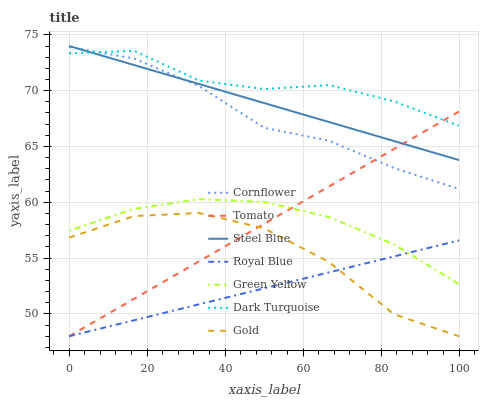Does Royal Blue have the minimum area under the curve?
Answer yes or no. Yes. Does Dark Turquoise have the maximum area under the curve?
Answer yes or no. Yes. Does Cornflower have the minimum area under the curve?
Answer yes or no. No. Does Cornflower have the maximum area under the curve?
Answer yes or no. No. Is Royal Blue the smoothest?
Answer yes or no. Yes. Is Gold the roughest?
Answer yes or no. Yes. Is Cornflower the smoothest?
Answer yes or no. No. Is Cornflower the roughest?
Answer yes or no. No. Does Tomato have the lowest value?
Answer yes or no. Yes. Does Cornflower have the lowest value?
Answer yes or no. No. Does Steel Blue have the highest value?
Answer yes or no. Yes. Does Cornflower have the highest value?
Answer yes or no. No. Is Royal Blue less than Dark Turquoise?
Answer yes or no. Yes. Is Steel Blue greater than Gold?
Answer yes or no. Yes. Does Steel Blue intersect Tomato?
Answer yes or no. Yes. Is Steel Blue less than Tomato?
Answer yes or no. No. Is Steel Blue greater than Tomato?
Answer yes or no. No. Does Royal Blue intersect Dark Turquoise?
Answer yes or no. No. 